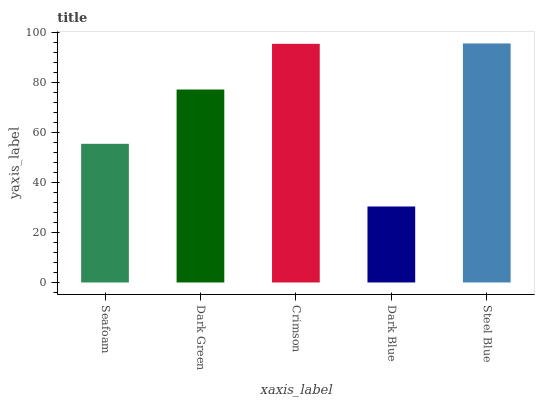Is Dark Green the minimum?
Answer yes or no. No. Is Dark Green the maximum?
Answer yes or no. No. Is Dark Green greater than Seafoam?
Answer yes or no. Yes. Is Seafoam less than Dark Green?
Answer yes or no. Yes. Is Seafoam greater than Dark Green?
Answer yes or no. No. Is Dark Green less than Seafoam?
Answer yes or no. No. Is Dark Green the high median?
Answer yes or no. Yes. Is Dark Green the low median?
Answer yes or no. Yes. Is Seafoam the high median?
Answer yes or no. No. Is Steel Blue the low median?
Answer yes or no. No. 